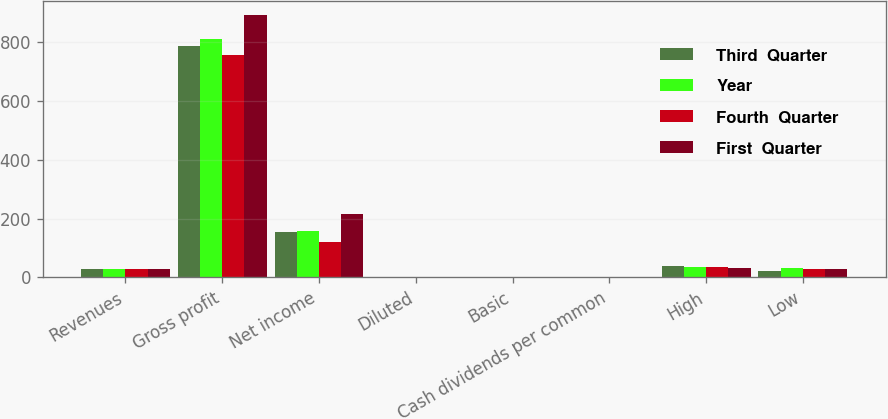Convert chart to OTSL. <chart><loc_0><loc_0><loc_500><loc_500><stacked_bar_chart><ecel><fcel>Revenues<fcel>Gross profit<fcel>Net income<fcel>Diluted<fcel>Basic<fcel>Cash dividends per common<fcel>High<fcel>Low<nl><fcel>Third  Quarter<fcel>27.55<fcel>786.5<fcel>155.6<fcel>0.53<fcel>0.54<fcel>0.06<fcel>37.1<fcel>22.6<nl><fcel>Year<fcel>27.55<fcel>811.7<fcel>156.5<fcel>0.53<fcel>0.54<fcel>0.06<fcel>36.7<fcel>31.9<nl><fcel>Fourth  Quarter<fcel>27.55<fcel>755.5<fcel>120.2<fcel>0.41<fcel>0.41<fcel>0.06<fcel>34.8<fcel>28.1<nl><fcel>First  Quarter<fcel>27.55<fcel>894.5<fcel>214.2<fcel>0.73<fcel>0.74<fcel>0.06<fcel>32<fcel>27<nl></chart> 